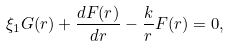<formula> <loc_0><loc_0><loc_500><loc_500>\xi _ { 1 } G ( r ) + \frac { d F ( r ) } { d r } - \frac { k } { r } F ( r ) = 0 ,</formula> 